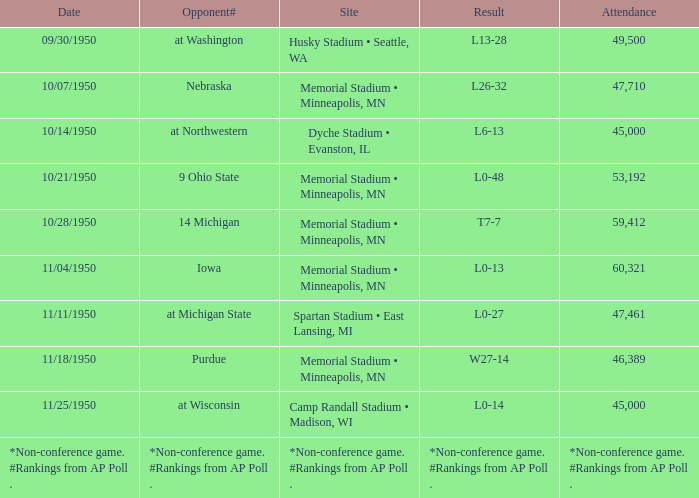Parse the full table. {'header': ['Date', 'Opponent#', 'Site', 'Result', 'Attendance'], 'rows': [['09/30/1950', 'at Washington', 'Husky Stadium • Seattle, WA', 'L13-28', '49,500'], ['10/07/1950', 'Nebraska', 'Memorial Stadium • Minneapolis, MN', 'L26-32', '47,710'], ['10/14/1950', 'at Northwestern', 'Dyche Stadium • Evanston, IL', 'L6-13', '45,000'], ['10/21/1950', '9 Ohio State', 'Memorial Stadium • Minneapolis, MN', 'L0-48', '53,192'], ['10/28/1950', '14 Michigan', 'Memorial Stadium • Minneapolis, MN', 'T7-7', '59,412'], ['11/04/1950', 'Iowa', 'Memorial Stadium • Minneapolis, MN', 'L0-13', '60,321'], ['11/11/1950', 'at Michigan State', 'Spartan Stadium • East Lansing, MI', 'L0-27', '47,461'], ['11/18/1950', 'Purdue', 'Memorial Stadium • Minneapolis, MN', 'W27-14', '46,389'], ['11/25/1950', 'at Wisconsin', 'Camp Randall Stadium • Madison, WI', 'L0-14', '45,000'], ['*Non-conference game. #Rankings from AP Poll .', '*Non-conference game. #Rankings from AP Poll .', '*Non-conference game. #Rankings from AP Poll .', '*Non-conference game. #Rankings from AP Poll .', '*Non-conference game. #Rankings from AP Poll .']]} What is the Site when the date is 11/11/1950? Spartan Stadium • East Lansing, MI. 